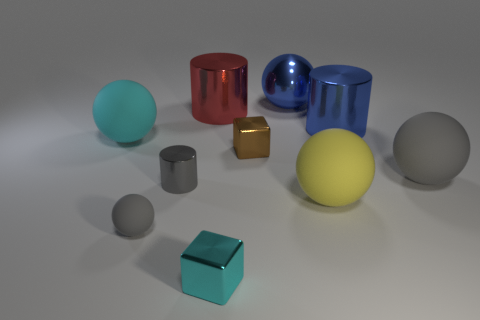Subtract all gray balls. How many were subtracted if there are1gray balls left? 1 Subtract all large red cylinders. How many cylinders are left? 2 Subtract 1 blocks. How many blocks are left? 1 Subtract all cylinders. How many objects are left? 7 Subtract all purple cylinders. How many red blocks are left? 0 Add 1 big blue cylinders. How many big blue cylinders are left? 2 Add 8 tiny gray shiny objects. How many tiny gray shiny objects exist? 9 Subtract all gray spheres. How many spheres are left? 3 Subtract 0 brown balls. How many objects are left? 10 Subtract all purple blocks. Subtract all yellow cylinders. How many blocks are left? 2 